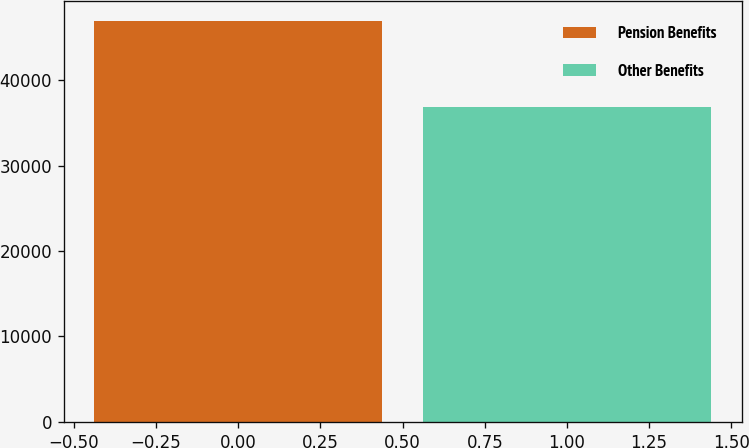Convert chart. <chart><loc_0><loc_0><loc_500><loc_500><bar_chart><fcel>Pension Benefits<fcel>Other Benefits<nl><fcel>46877<fcel>36861<nl></chart> 